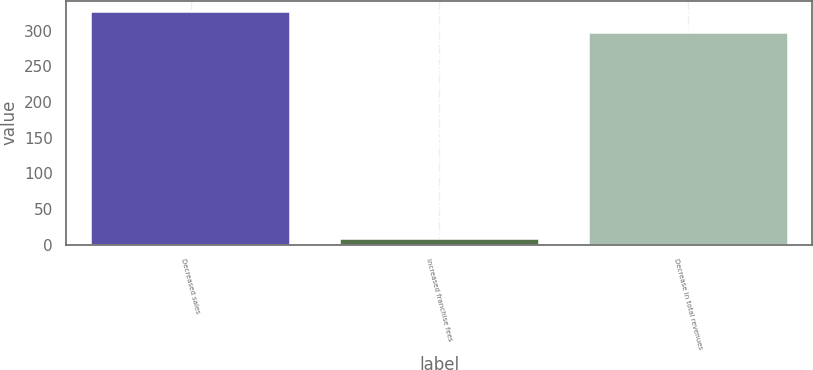Convert chart to OTSL. <chart><loc_0><loc_0><loc_500><loc_500><bar_chart><fcel>Decreased sales<fcel>Increased franchise fees<fcel>Decrease in total revenues<nl><fcel>325.6<fcel>8<fcel>296<nl></chart> 